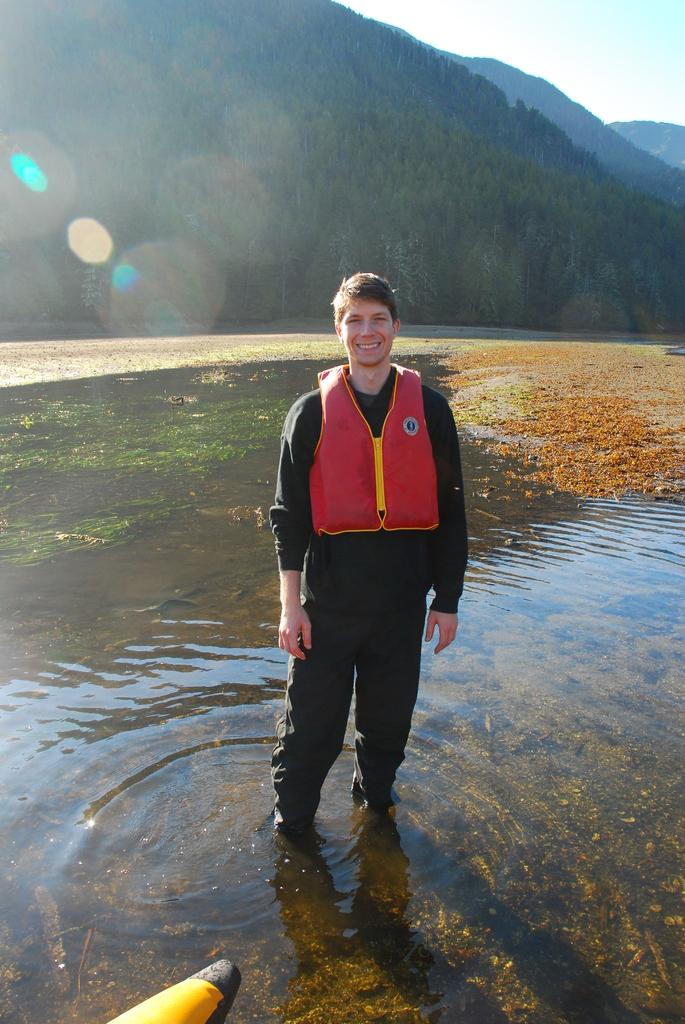What is the person in the image doing? The person is standing in the water. How does the person appear to feel in the image? The person is wearing a smile on his face. What can be seen in the background of the image? There are trees, mountains, and the sky visible in the background of the image. How many numbers can be seen floating in the water in the image? There are no numbers visible in the water in the image. Is there an island in the background of the image? There is no island present in the image; the background features trees, mountains, and the sky. 